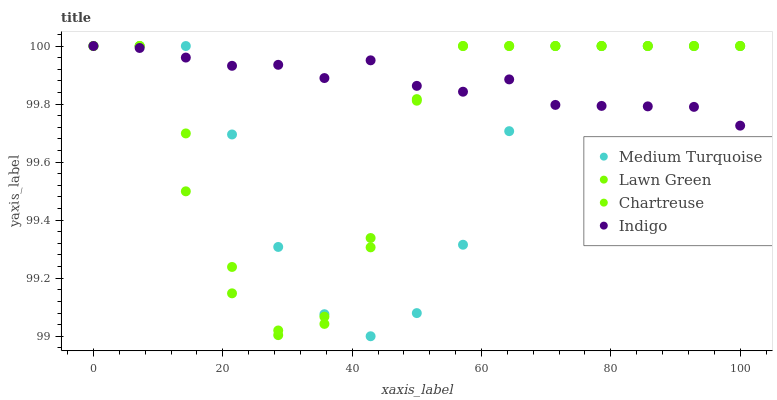Does Medium Turquoise have the minimum area under the curve?
Answer yes or no. Yes. Does Indigo have the maximum area under the curve?
Answer yes or no. Yes. Does Chartreuse have the minimum area under the curve?
Answer yes or no. No. Does Chartreuse have the maximum area under the curve?
Answer yes or no. No. Is Indigo the smoothest?
Answer yes or no. Yes. Is Lawn Green the roughest?
Answer yes or no. Yes. Is Chartreuse the smoothest?
Answer yes or no. No. Is Chartreuse the roughest?
Answer yes or no. No. Does Medium Turquoise have the lowest value?
Answer yes or no. Yes. Does Chartreuse have the lowest value?
Answer yes or no. No. Does Medium Turquoise have the highest value?
Answer yes or no. Yes. Does Chartreuse intersect Indigo?
Answer yes or no. Yes. Is Chartreuse less than Indigo?
Answer yes or no. No. Is Chartreuse greater than Indigo?
Answer yes or no. No. 